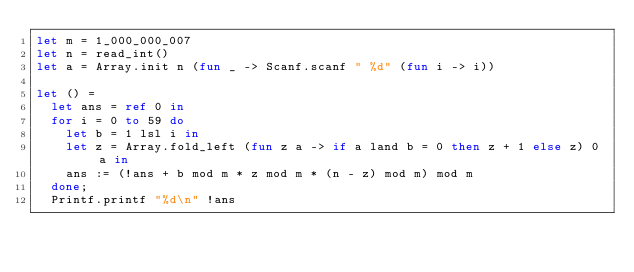Convert code to text. <code><loc_0><loc_0><loc_500><loc_500><_OCaml_>let m = 1_000_000_007
let n = read_int()
let a = Array.init n (fun _ -> Scanf.scanf " %d" (fun i -> i))

let () =
  let ans = ref 0 in
  for i = 0 to 59 do
    let b = 1 lsl i in
    let z = Array.fold_left (fun z a -> if a land b = 0 then z + 1 else z) 0 a in
    ans := (!ans + b mod m * z mod m * (n - z) mod m) mod m
  done;
  Printf.printf "%d\n" !ans
</code> 